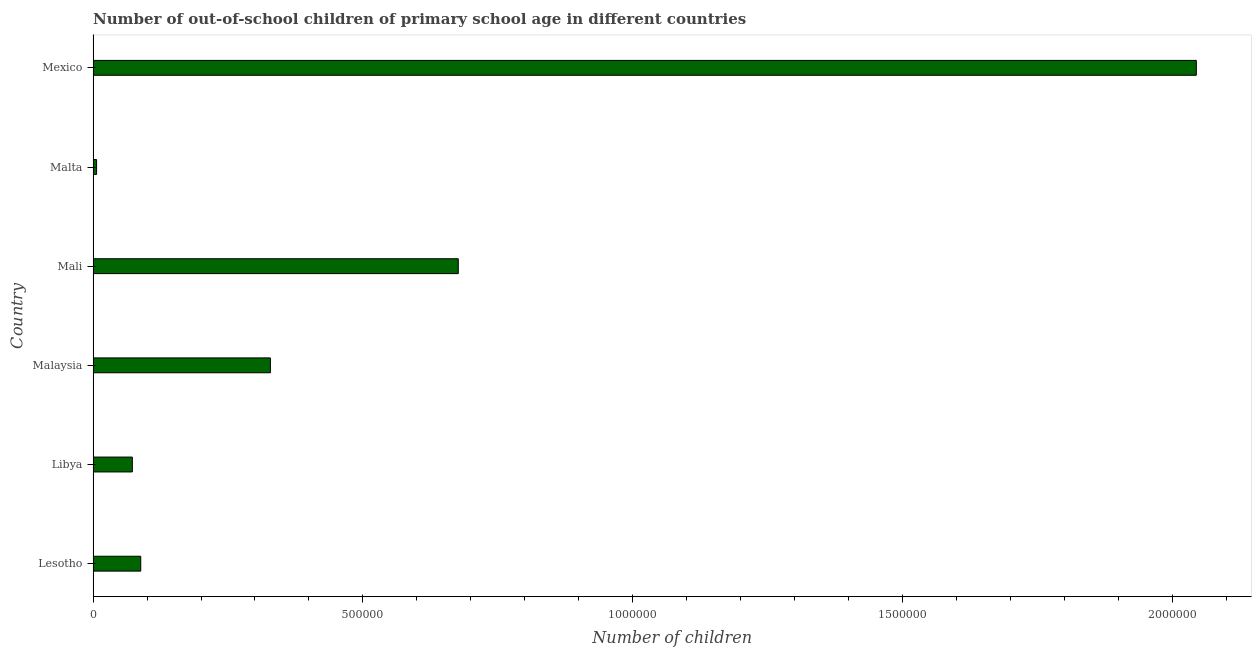What is the title of the graph?
Your answer should be very brief. Number of out-of-school children of primary school age in different countries. What is the label or title of the X-axis?
Offer a terse response. Number of children. What is the number of out-of-school children in Libya?
Provide a succinct answer. 7.27e+04. Across all countries, what is the maximum number of out-of-school children?
Give a very brief answer. 2.04e+06. Across all countries, what is the minimum number of out-of-school children?
Your answer should be compact. 6499. In which country was the number of out-of-school children minimum?
Make the answer very short. Malta. What is the sum of the number of out-of-school children?
Offer a terse response. 3.22e+06. What is the difference between the number of out-of-school children in Libya and Malaysia?
Keep it short and to the point. -2.56e+05. What is the average number of out-of-school children per country?
Your answer should be compact. 5.36e+05. What is the median number of out-of-school children?
Make the answer very short. 2.08e+05. What is the ratio of the number of out-of-school children in Lesotho to that in Malaysia?
Ensure brevity in your answer.  0.27. What is the difference between the highest and the second highest number of out-of-school children?
Keep it short and to the point. 1.37e+06. Is the sum of the number of out-of-school children in Mali and Mexico greater than the maximum number of out-of-school children across all countries?
Ensure brevity in your answer.  Yes. What is the difference between the highest and the lowest number of out-of-school children?
Provide a short and direct response. 2.04e+06. Are all the bars in the graph horizontal?
Provide a succinct answer. Yes. How many countries are there in the graph?
Your answer should be very brief. 6. Are the values on the major ticks of X-axis written in scientific E-notation?
Offer a very short reply. No. What is the Number of children in Lesotho?
Your answer should be compact. 8.83e+04. What is the Number of children in Libya?
Provide a short and direct response. 7.27e+04. What is the Number of children in Malaysia?
Offer a terse response. 3.29e+05. What is the Number of children in Mali?
Ensure brevity in your answer.  6.77e+05. What is the Number of children of Malta?
Provide a succinct answer. 6499. What is the Number of children of Mexico?
Offer a very short reply. 2.04e+06. What is the difference between the Number of children in Lesotho and Libya?
Offer a terse response. 1.56e+04. What is the difference between the Number of children in Lesotho and Malaysia?
Give a very brief answer. -2.40e+05. What is the difference between the Number of children in Lesotho and Mali?
Keep it short and to the point. -5.88e+05. What is the difference between the Number of children in Lesotho and Malta?
Offer a very short reply. 8.18e+04. What is the difference between the Number of children in Lesotho and Mexico?
Keep it short and to the point. -1.96e+06. What is the difference between the Number of children in Libya and Malaysia?
Your answer should be very brief. -2.56e+05. What is the difference between the Number of children in Libya and Mali?
Offer a very short reply. -6.04e+05. What is the difference between the Number of children in Libya and Malta?
Provide a short and direct response. 6.62e+04. What is the difference between the Number of children in Libya and Mexico?
Provide a short and direct response. -1.97e+06. What is the difference between the Number of children in Malaysia and Mali?
Your answer should be compact. -3.48e+05. What is the difference between the Number of children in Malaysia and Malta?
Keep it short and to the point. 3.22e+05. What is the difference between the Number of children in Malaysia and Mexico?
Provide a short and direct response. -1.72e+06. What is the difference between the Number of children in Mali and Malta?
Give a very brief answer. 6.70e+05. What is the difference between the Number of children in Mali and Mexico?
Make the answer very short. -1.37e+06. What is the difference between the Number of children in Malta and Mexico?
Keep it short and to the point. -2.04e+06. What is the ratio of the Number of children in Lesotho to that in Libya?
Provide a succinct answer. 1.21. What is the ratio of the Number of children in Lesotho to that in Malaysia?
Your answer should be very brief. 0.27. What is the ratio of the Number of children in Lesotho to that in Mali?
Provide a short and direct response. 0.13. What is the ratio of the Number of children in Lesotho to that in Malta?
Your response must be concise. 13.59. What is the ratio of the Number of children in Lesotho to that in Mexico?
Provide a succinct answer. 0.04. What is the ratio of the Number of children in Libya to that in Malaysia?
Make the answer very short. 0.22. What is the ratio of the Number of children in Libya to that in Mali?
Ensure brevity in your answer.  0.11. What is the ratio of the Number of children in Libya to that in Malta?
Offer a terse response. 11.19. What is the ratio of the Number of children in Libya to that in Mexico?
Keep it short and to the point. 0.04. What is the ratio of the Number of children in Malaysia to that in Mali?
Provide a succinct answer. 0.49. What is the ratio of the Number of children in Malaysia to that in Malta?
Make the answer very short. 50.56. What is the ratio of the Number of children in Malaysia to that in Mexico?
Ensure brevity in your answer.  0.16. What is the ratio of the Number of children in Mali to that in Malta?
Provide a short and direct response. 104.14. What is the ratio of the Number of children in Mali to that in Mexico?
Offer a terse response. 0.33. What is the ratio of the Number of children in Malta to that in Mexico?
Offer a very short reply. 0. 